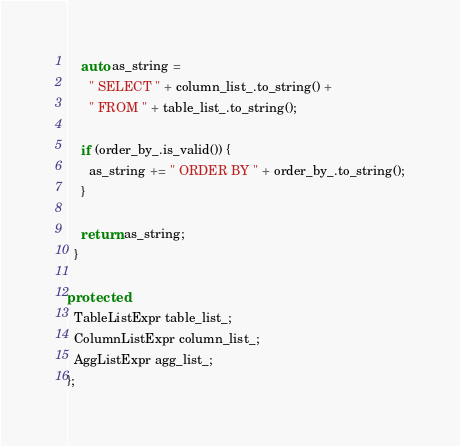<code> <loc_0><loc_0><loc_500><loc_500><_C++_>    auto as_string =
      " SELECT " + column_list_.to_string() +
      " FROM " + table_list_.to_string();

    if (order_by_.is_valid()) {
      as_string += " ORDER BY " + order_by_.to_string();
    }

    return as_string;
  }

protected:
  TableListExpr table_list_;
  ColumnListExpr column_list_;
  AggListExpr agg_list_;
};
</code> 